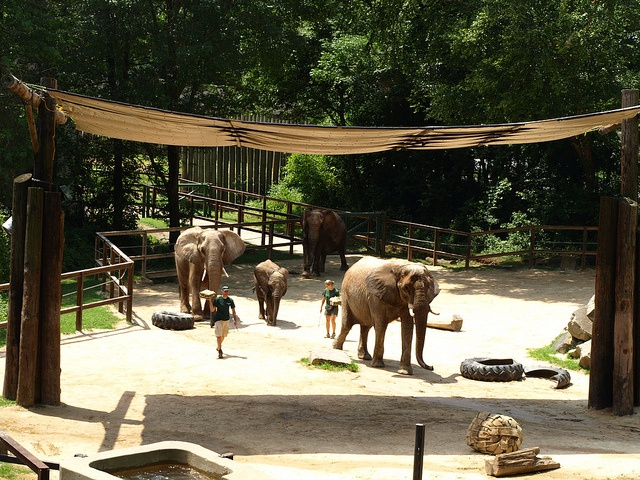Describe the objects in this image and their specific colors. I can see elephant in black, maroon, and ivory tones, elephant in black, maroon, and gray tones, elephant in black and gray tones, elephant in black, maroon, and gray tones, and people in black, tan, brown, and gray tones in this image. 